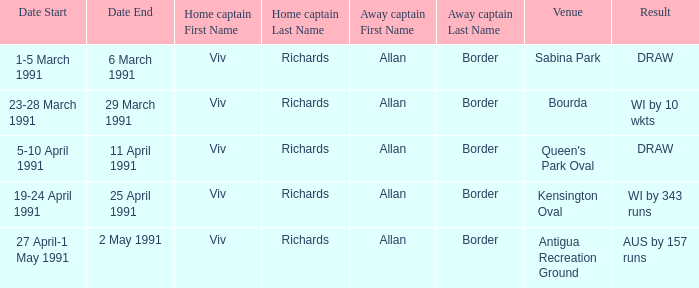Which venues resulted in a draw? Sabina Park, Queen's Park Oval. 